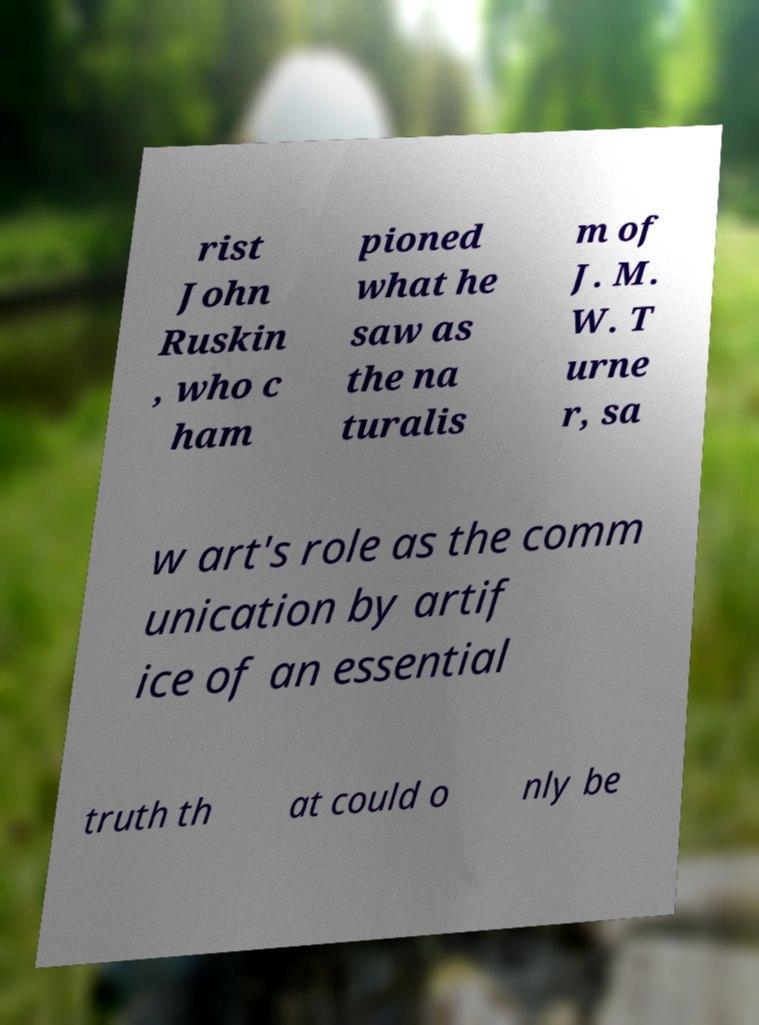Could you assist in decoding the text presented in this image and type it out clearly? rist John Ruskin , who c ham pioned what he saw as the na turalis m of J. M. W. T urne r, sa w art's role as the comm unication by artif ice of an essential truth th at could o nly be 